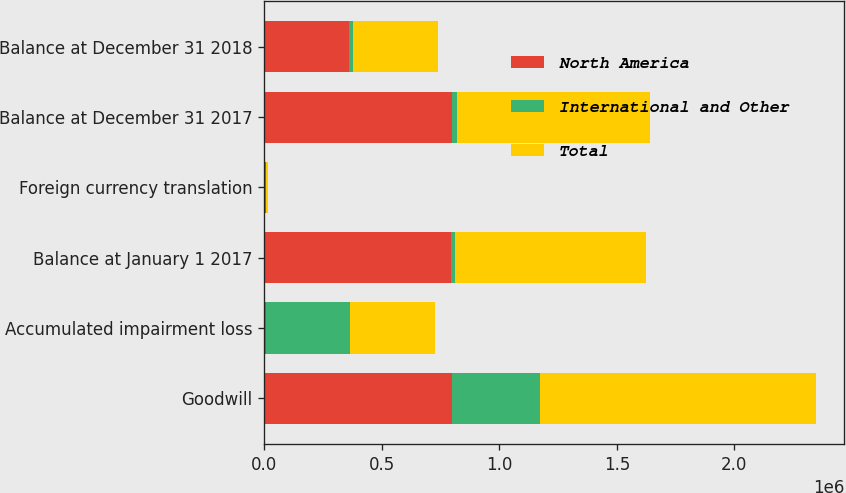Convert chart to OTSL. <chart><loc_0><loc_0><loc_500><loc_500><stacked_bar_chart><ecel><fcel>Goodwill<fcel>Accumulated impairment loss<fcel>Balance at January 1 2017<fcel>Foreign currency translation<fcel>Balance at December 31 2017<fcel>Balance at December 31 2018<nl><fcel>North America<fcel>797163<fcel>4973<fcel>792190<fcel>7739<fcel>799929<fcel>359862<nl><fcel>International and Other<fcel>377529<fcel>357375<fcel>20154<fcel>978<fcel>21132<fcel>18258<nl><fcel>Total<fcel>1.17469e+06<fcel>362348<fcel>812344<fcel>8717<fcel>821061<fcel>359862<nl></chart> 